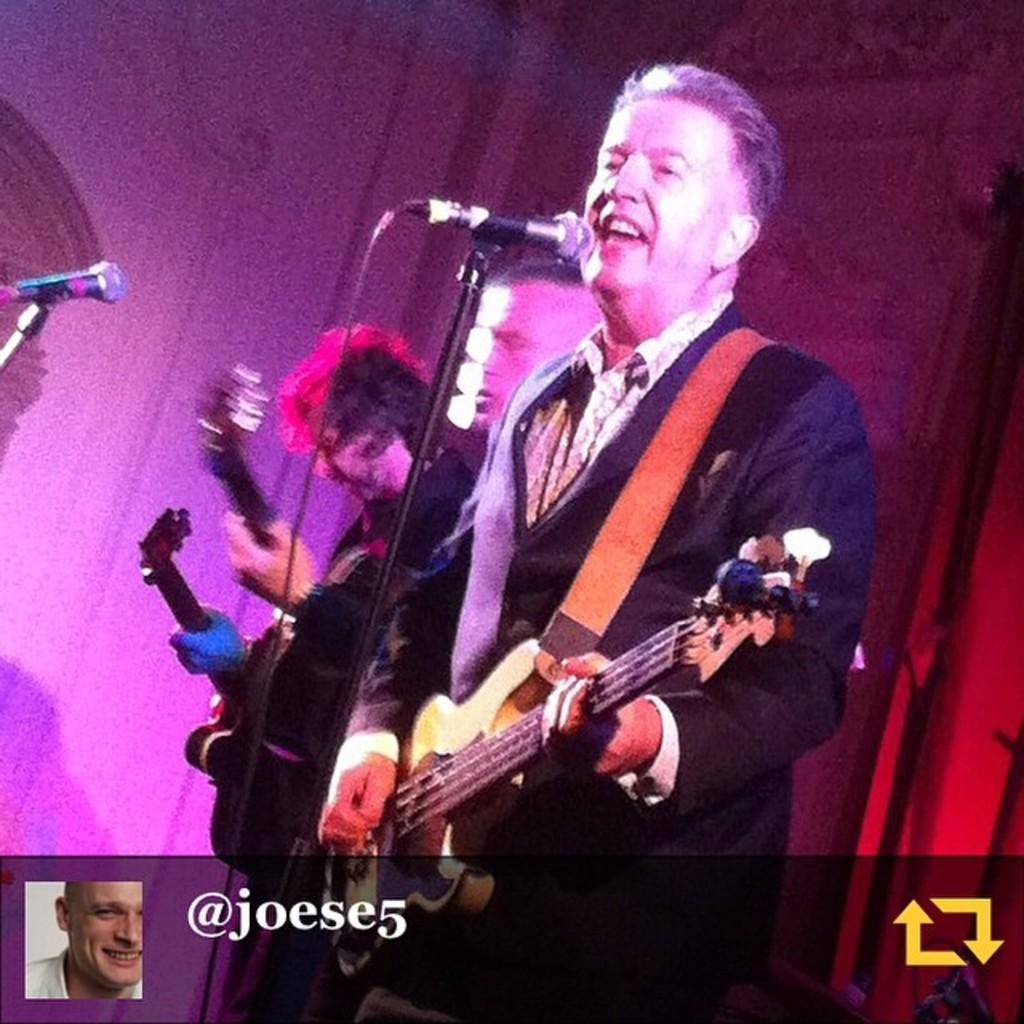Please provide a concise description of this image. A man is standing by holding a guitar in his hands and he is singing in the microphone. 